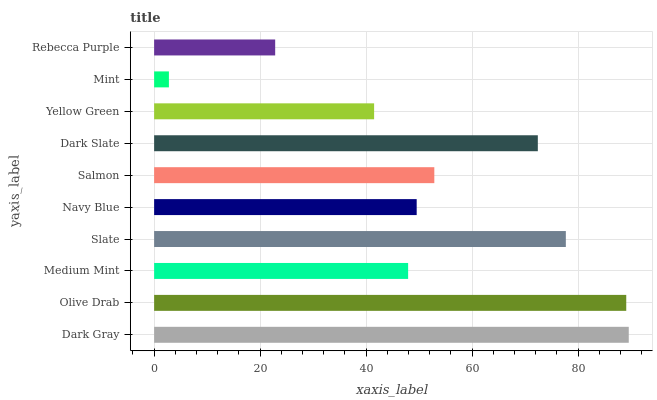Is Mint the minimum?
Answer yes or no. Yes. Is Dark Gray the maximum?
Answer yes or no. Yes. Is Olive Drab the minimum?
Answer yes or no. No. Is Olive Drab the maximum?
Answer yes or no. No. Is Dark Gray greater than Olive Drab?
Answer yes or no. Yes. Is Olive Drab less than Dark Gray?
Answer yes or no. Yes. Is Olive Drab greater than Dark Gray?
Answer yes or no. No. Is Dark Gray less than Olive Drab?
Answer yes or no. No. Is Salmon the high median?
Answer yes or no. Yes. Is Navy Blue the low median?
Answer yes or no. Yes. Is Rebecca Purple the high median?
Answer yes or no. No. Is Olive Drab the low median?
Answer yes or no. No. 